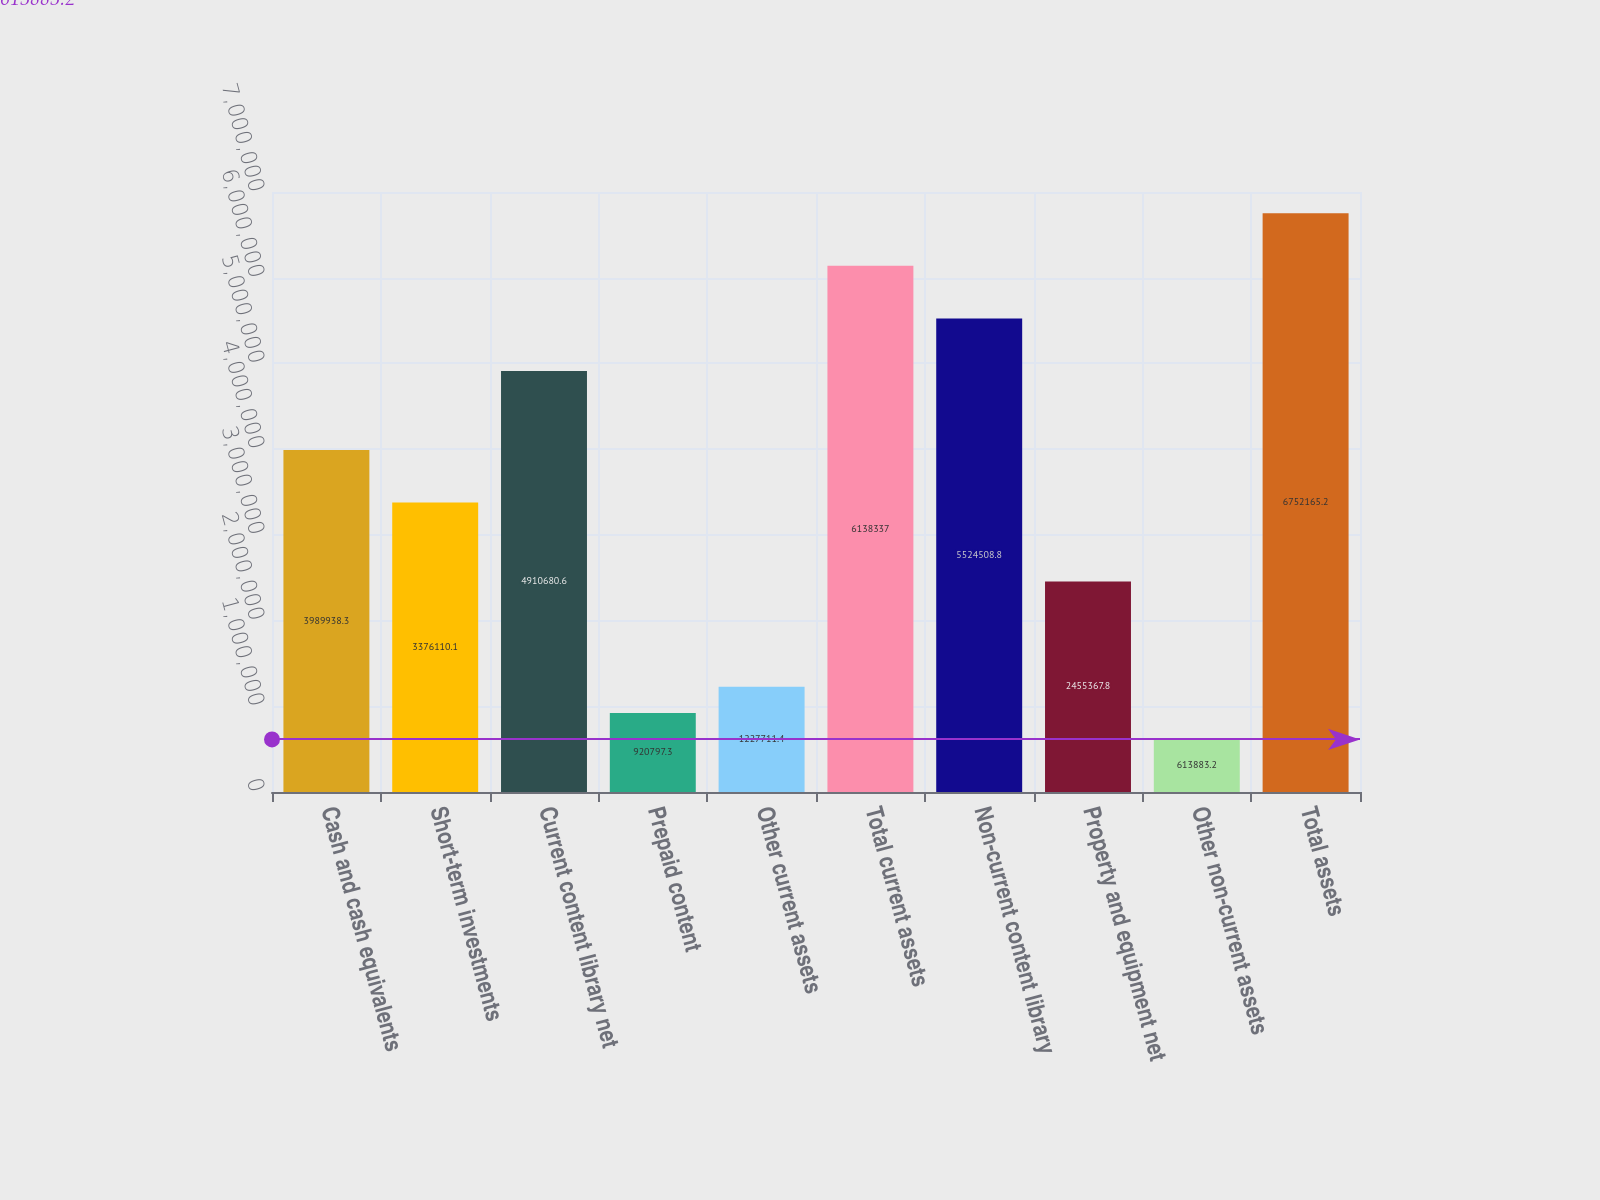<chart> <loc_0><loc_0><loc_500><loc_500><bar_chart><fcel>Cash and cash equivalents<fcel>Short-term investments<fcel>Current content library net<fcel>Prepaid content<fcel>Other current assets<fcel>Total current assets<fcel>Non-current content library<fcel>Property and equipment net<fcel>Other non-current assets<fcel>Total assets<nl><fcel>3.98994e+06<fcel>3.37611e+06<fcel>4.91068e+06<fcel>920797<fcel>1.22771e+06<fcel>6.13834e+06<fcel>5.52451e+06<fcel>2.45537e+06<fcel>613883<fcel>6.75217e+06<nl></chart> 